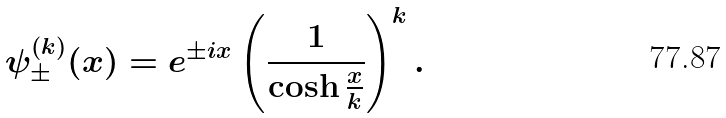Convert formula to latex. <formula><loc_0><loc_0><loc_500><loc_500>\psi _ { \pm } ^ { ( k ) } ( x ) = e ^ { \pm i x } \left ( \frac { 1 } { \cosh \frac { x } { k } } \right ) ^ { k } .</formula> 